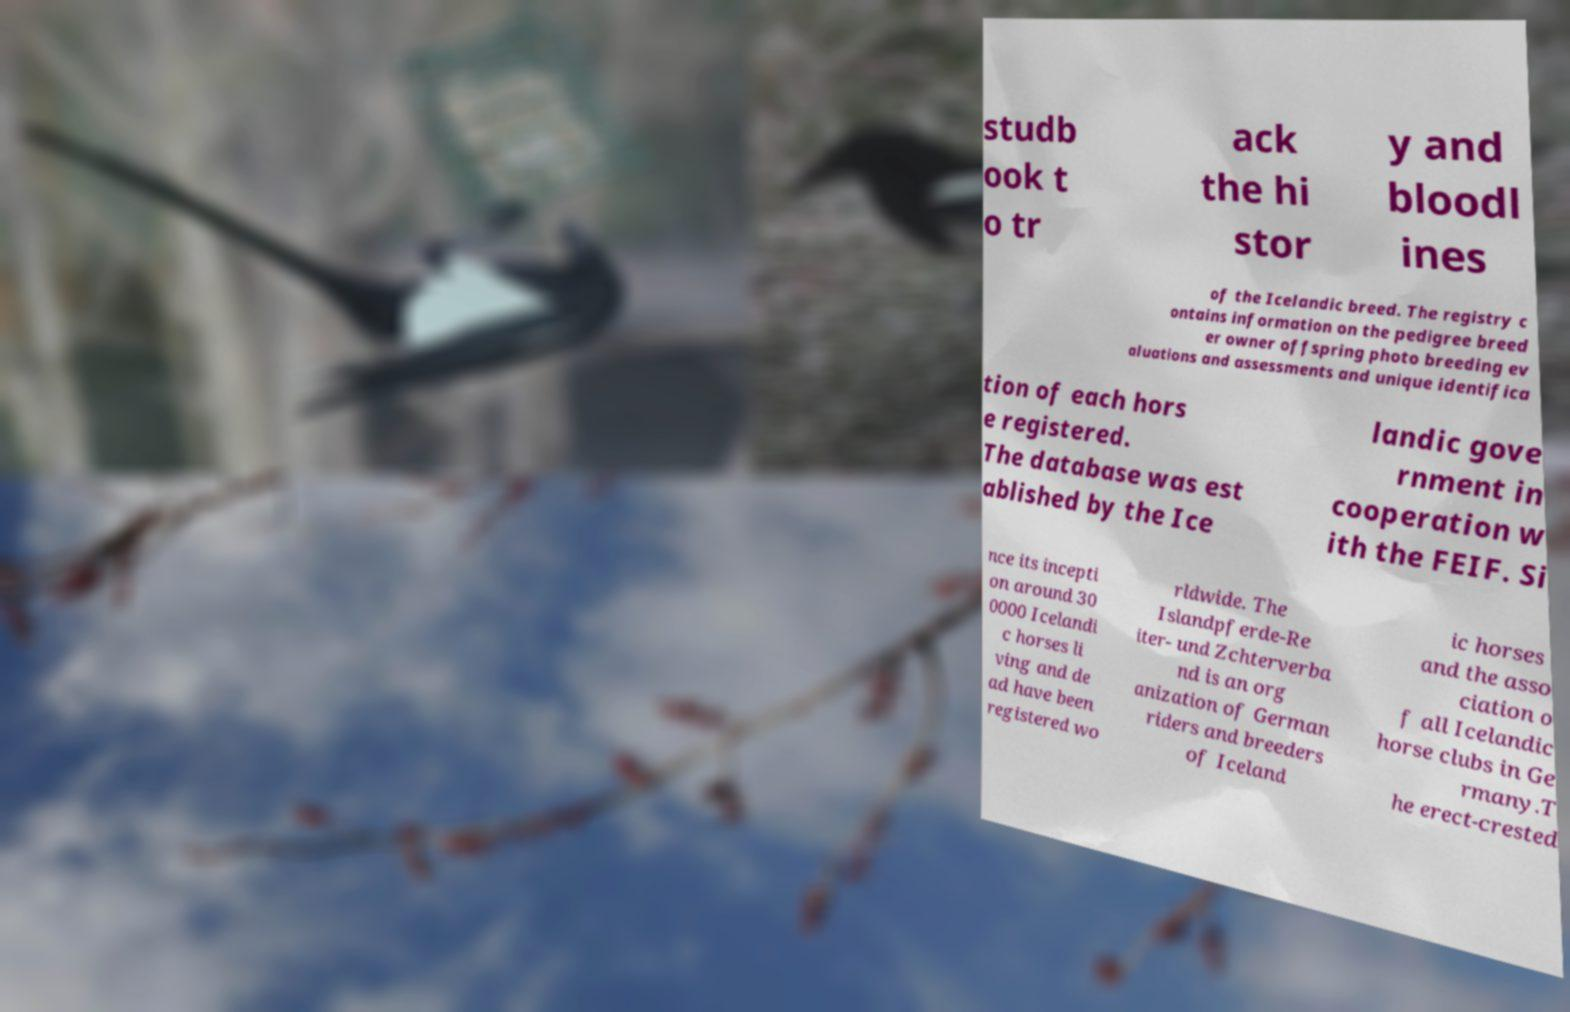For documentation purposes, I need the text within this image transcribed. Could you provide that? studb ook t o tr ack the hi stor y and bloodl ines of the Icelandic breed. The registry c ontains information on the pedigree breed er owner offspring photo breeding ev aluations and assessments and unique identifica tion of each hors e registered. The database was est ablished by the Ice landic gove rnment in cooperation w ith the FEIF. Si nce its incepti on around 30 0000 Icelandi c horses li ving and de ad have been registered wo rldwide. The Islandpferde-Re iter- und Zchterverba nd is an org anization of German riders and breeders of Iceland ic horses and the asso ciation o f all Icelandic horse clubs in Ge rmany.T he erect-crested 